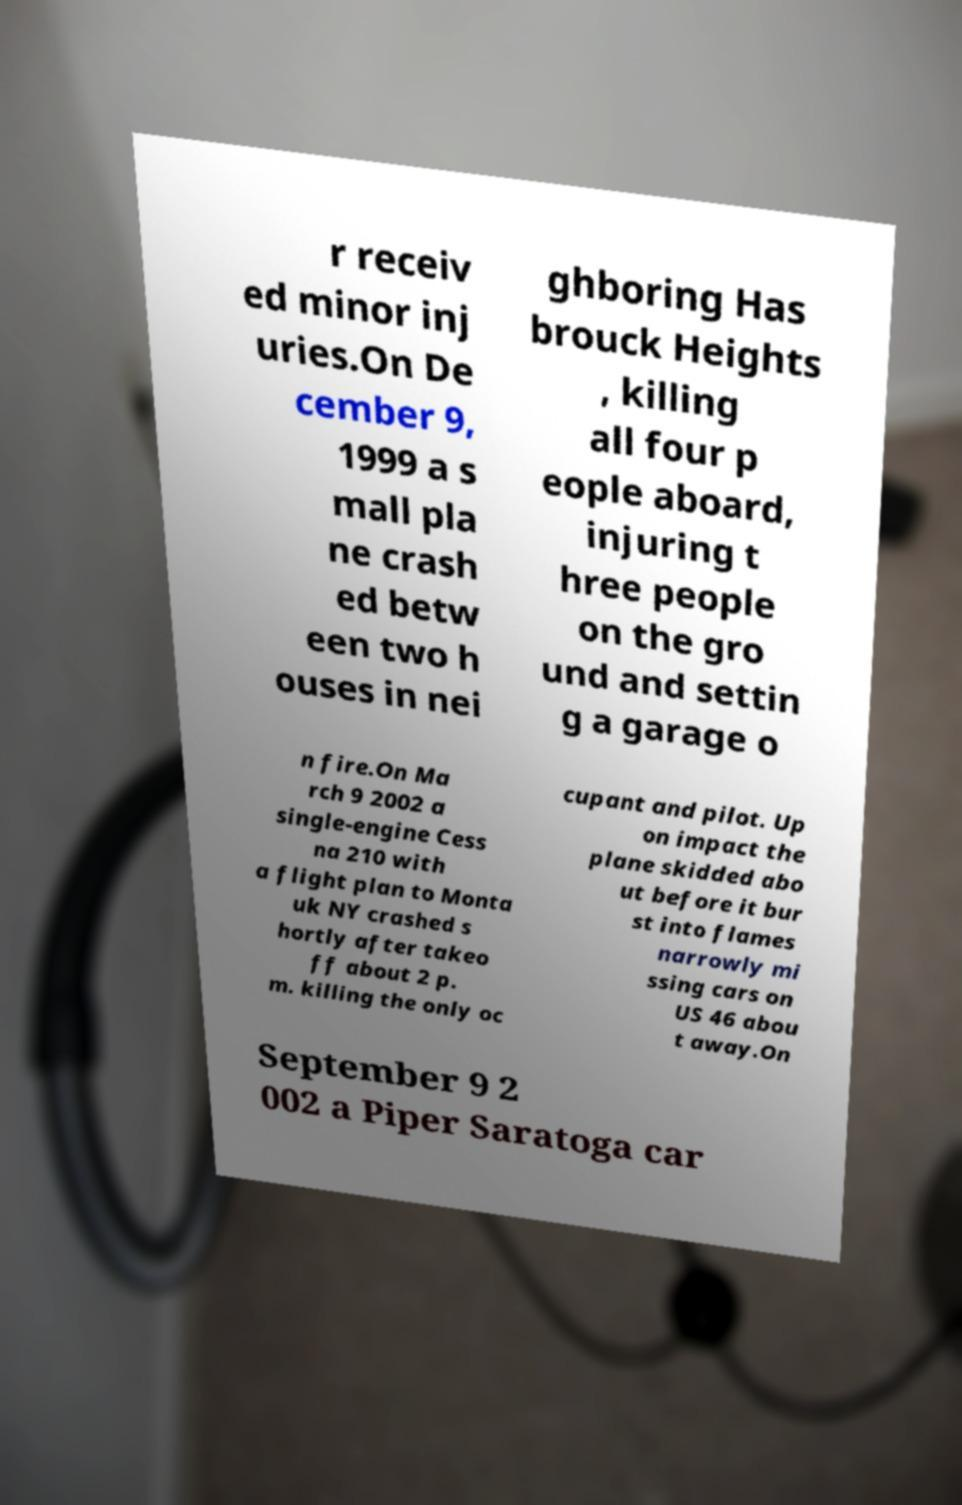Please identify and transcribe the text found in this image. r receiv ed minor inj uries.On De cember 9, 1999 a s mall pla ne crash ed betw een two h ouses in nei ghboring Has brouck Heights , killing all four p eople aboard, injuring t hree people on the gro und and settin g a garage o n fire.On Ma rch 9 2002 a single-engine Cess na 210 with a flight plan to Monta uk NY crashed s hortly after takeo ff about 2 p. m. killing the only oc cupant and pilot. Up on impact the plane skidded abo ut before it bur st into flames narrowly mi ssing cars on US 46 abou t away.On September 9 2 002 a Piper Saratoga car 